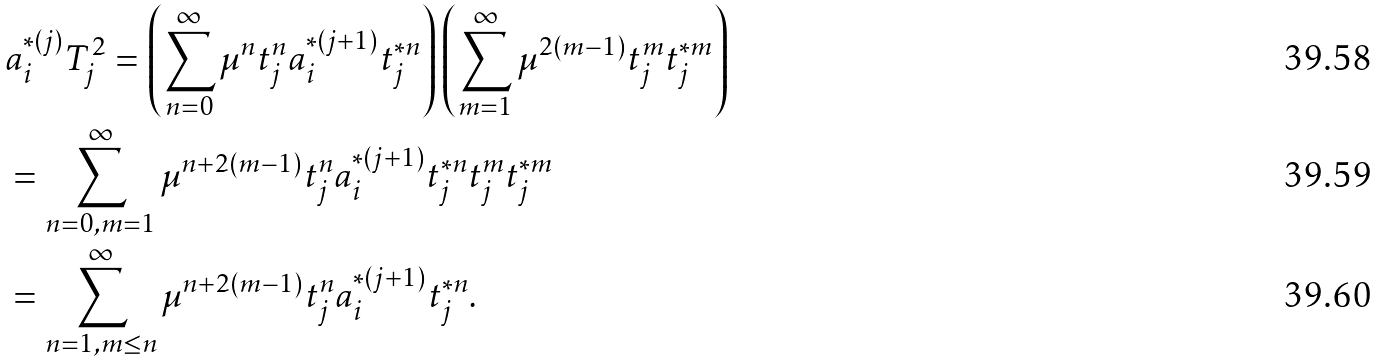Convert formula to latex. <formula><loc_0><loc_0><loc_500><loc_500>& a _ { i } ^ { * ( j ) } T _ { j } ^ { 2 } = \left ( \sum _ { n = 0 } ^ { \infty } \mu ^ { n } t _ { j } ^ { n } a _ { i } ^ { * ( j + 1 ) } t _ { j } ^ { * n } \right ) \left ( \sum _ { m = 1 } ^ { \infty } \mu ^ { 2 ( m - 1 ) } t _ { j } ^ { m } t _ { j } ^ { * m } \right ) \\ & = \sum _ { n = 0 , m = 1 } ^ { \infty } \mu ^ { n + 2 ( m - 1 ) } t _ { j } ^ { n } a _ { i } ^ { * ( j + 1 ) } t _ { j } ^ { * n } t _ { j } ^ { m } t _ { j } ^ { * m } \\ & = \sum _ { n = 1 , m \leq n } ^ { \infty } \mu ^ { n + 2 ( m - 1 ) } t _ { j } ^ { n } a _ { i } ^ { * ( j + 1 ) } t _ { j } ^ { * n } .</formula> 